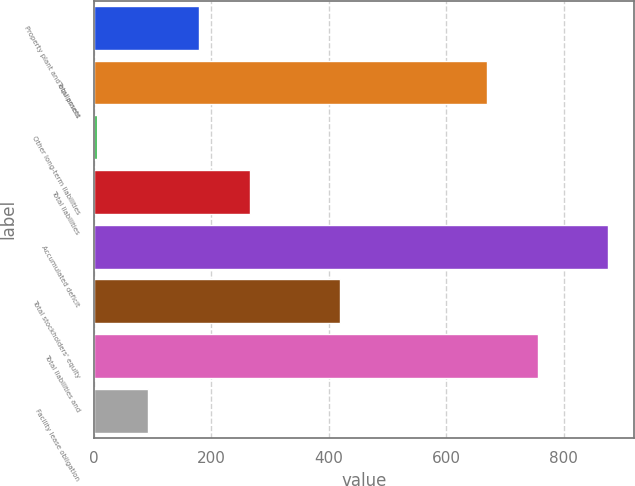Convert chart to OTSL. <chart><loc_0><loc_0><loc_500><loc_500><bar_chart><fcel>Property plant and equipment<fcel>Total assets<fcel>Other long-term liabilities<fcel>Total liabilities<fcel>Accumulated deficit<fcel>Total stockholders' equity<fcel>Total liabilities and<fcel>Facility lease obligation<nl><fcel>179.26<fcel>670<fcel>5.1<fcel>266.34<fcel>875.9<fcel>418.8<fcel>757.08<fcel>92.18<nl></chart> 